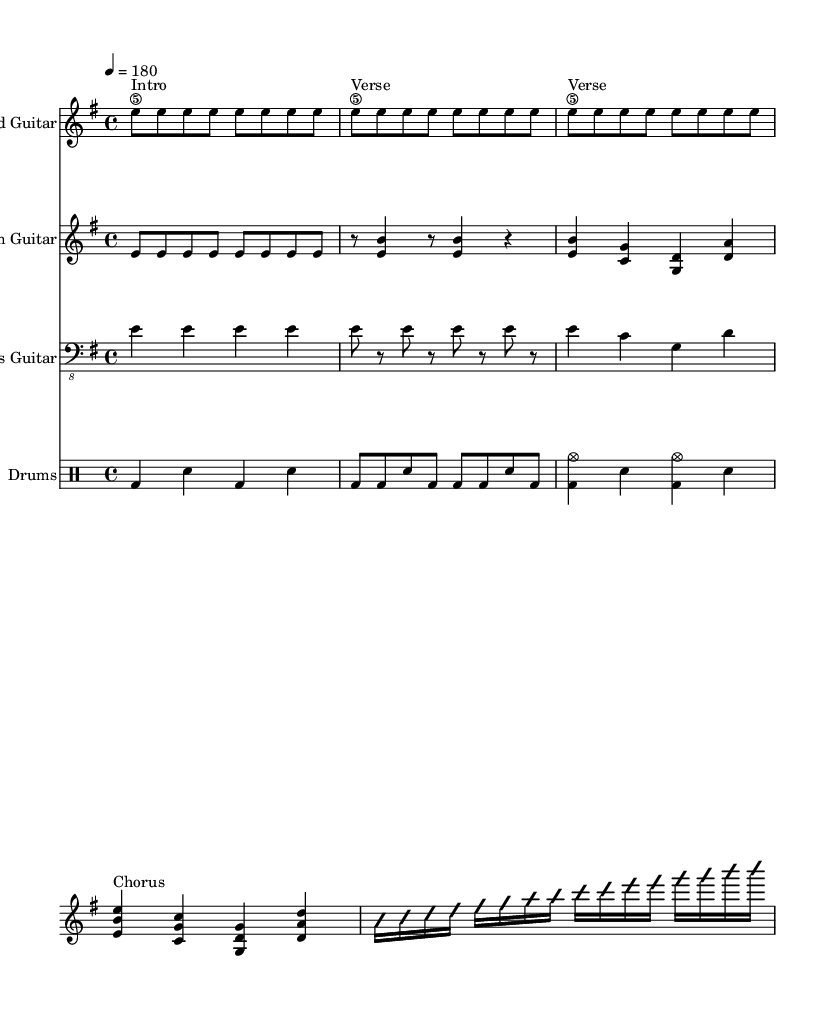What is the key signature of this music? The key signature is E minor, which has one sharp (F#). This can be identified from the first part of the sheet music where the key is indicated by the symbol placed at the beginning of the staff.
Answer: E minor What is the time signature of this music? The time signature is 4/4, which is indicated at the beginning of the sheet music. This means there are four beats in each measure, and the quarter note gets one beat.
Answer: 4/4 What is the tempo marking? The tempo marking is 180 beats per minute, noted at the beginning of the score with the indication “4 = 180,” meaning the quarter note should be played at this speed.
Answer: 180 How many measures are in the chorus section? The chorus section consists of four measures. By looking at the segment labeled "Chorus," we can count four distinct measures for this section.
Answer: 4 Which instruments are included in the score? The score includes Lead Guitar, Rhythm Guitar, Bass Guitar, and Drums. This can be determined from the staff names indicated at the beginning of each instrumental part in the music sheet.
Answer: Lead Guitar, Rhythm Guitar, Bass Guitar, Drums What type of musical piece is this? This piece is classified as Rock/Heavy Metal given its structure, instrumentation, aggressive rhythm in the drumming, and the presence of guitar solos, typical characteristics of the genre.
Answer: Rock/Heavy Metal 